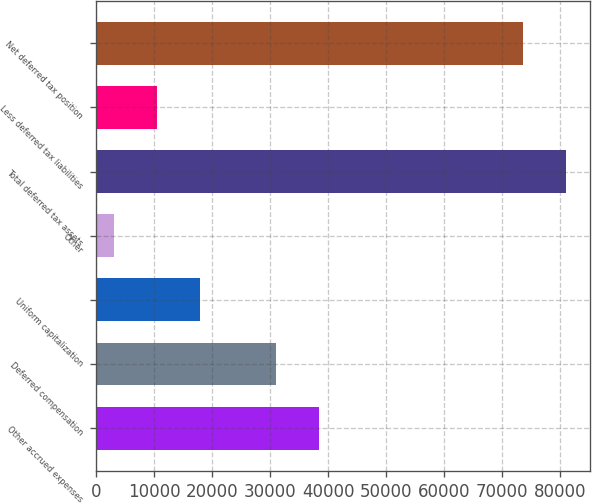Convert chart to OTSL. <chart><loc_0><loc_0><loc_500><loc_500><bar_chart><fcel>Other accrued expenses<fcel>Deferred compensation<fcel>Uniform capitalization<fcel>Other<fcel>Total deferred tax assets<fcel>Less deferred tax liabilities<fcel>Net deferred tax position<nl><fcel>38396.8<fcel>30973<fcel>17916.6<fcel>3069<fcel>81069.8<fcel>10492.8<fcel>73646<nl></chart> 